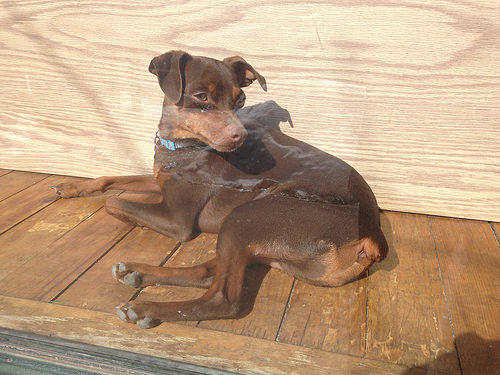<image>
Can you confirm if the dog is on the floor? Yes. Looking at the image, I can see the dog is positioned on top of the floor, with the floor providing support. 